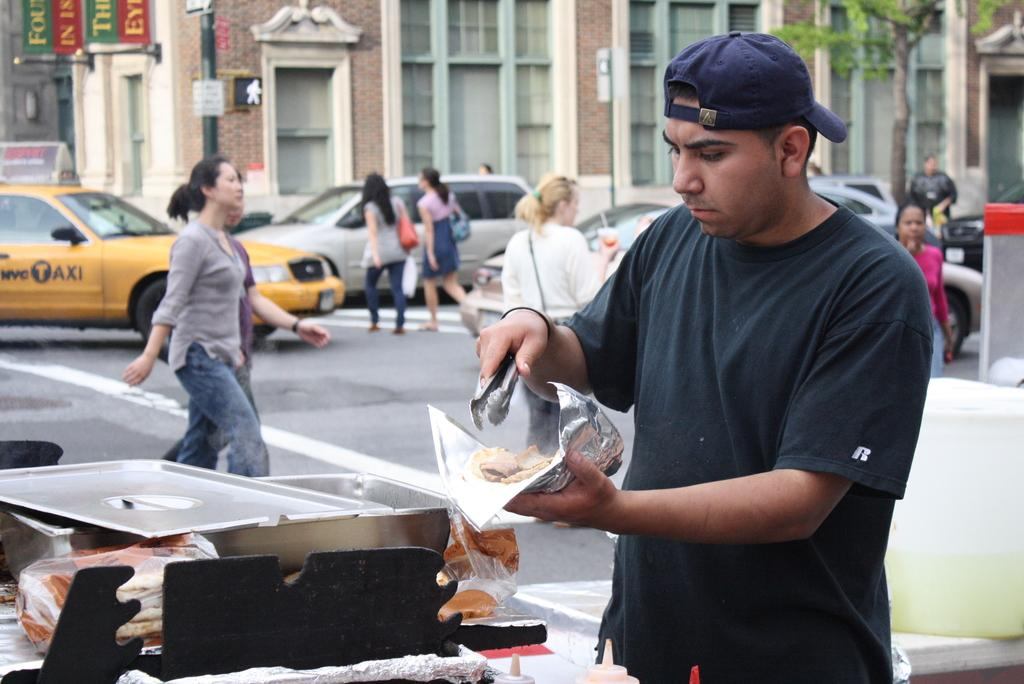<image>
Render a clear and concise summary of the photo. A man with an R on his t shirt is getting food on the roadside. 